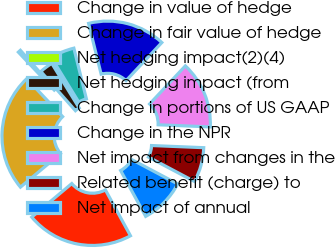Convert chart. <chart><loc_0><loc_0><loc_500><loc_500><pie_chart><fcel>Change in value of hedge<fcel>Change in fair value of hedge<fcel>Net hedging impact(2)(4)<fcel>Net hedging impact (from<fcel>Change in portions of US GAAP<fcel>Change in the NPR<fcel>Net impact from changes in the<fcel>Related benefit (charge) to<fcel>Net impact of annual<nl><fcel>21.86%<fcel>24.04%<fcel>0.55%<fcel>2.73%<fcel>4.92%<fcel>15.85%<fcel>13.66%<fcel>7.1%<fcel>9.29%<nl></chart> 